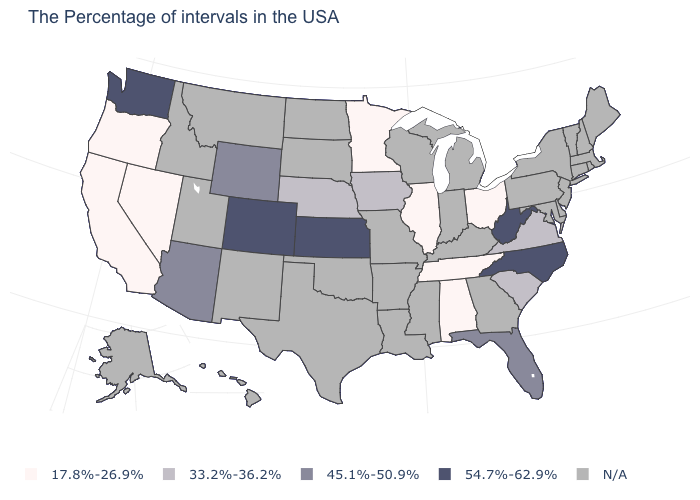Which states have the highest value in the USA?
Answer briefly. North Carolina, West Virginia, Kansas, Colorado, Washington. What is the value of Massachusetts?
Give a very brief answer. N/A. Among the states that border South Dakota , does Wyoming have the highest value?
Keep it brief. Yes. What is the value of North Carolina?
Write a very short answer. 54.7%-62.9%. Name the states that have a value in the range 33.2%-36.2%?
Answer briefly. Virginia, South Carolina, Iowa, Nebraska. What is the highest value in the USA?
Write a very short answer. 54.7%-62.9%. What is the highest value in the USA?
Concise answer only. 54.7%-62.9%. Among the states that border Oregon , which have the highest value?
Keep it brief. Washington. Does Kansas have the highest value in the MidWest?
Answer briefly. Yes. Does the first symbol in the legend represent the smallest category?
Concise answer only. Yes. What is the highest value in the South ?
Quick response, please. 54.7%-62.9%. Does Nebraska have the highest value in the USA?
Answer briefly. No. Which states have the highest value in the USA?
Give a very brief answer. North Carolina, West Virginia, Kansas, Colorado, Washington. 